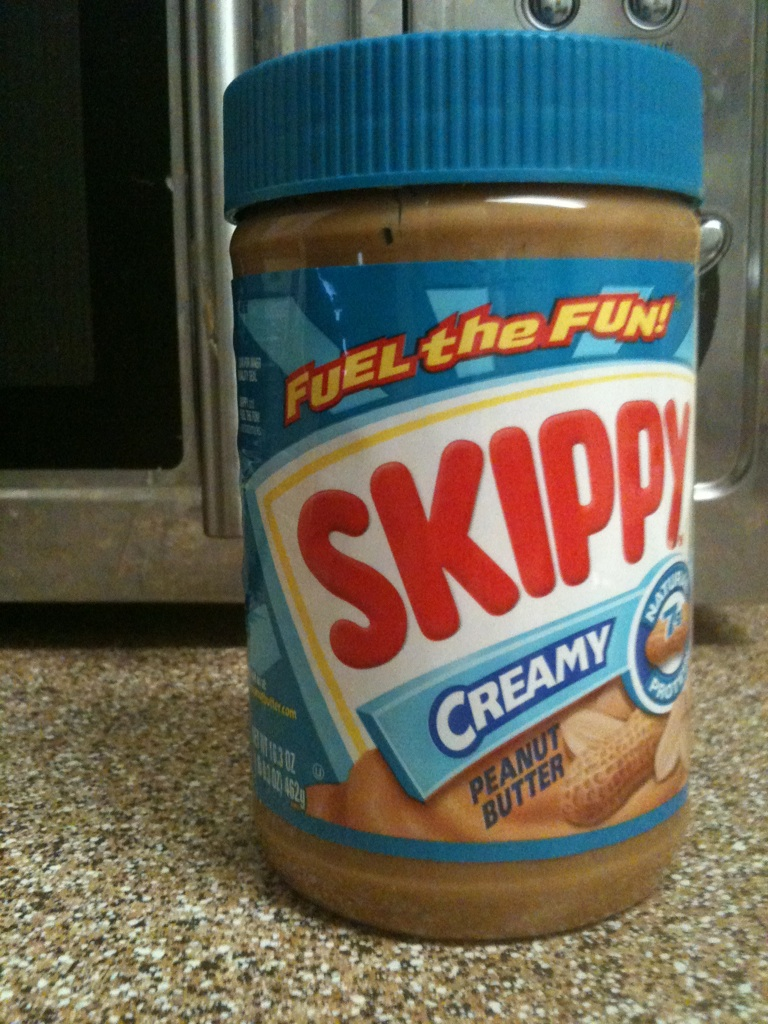What makes Skippy different from other peanut butter brands? Skippy is known for its unique, smooth texture and a slightly sweeter taste compared to some other brands. It uses a special blend of roasted peanuts to achieve its signature flavor and creamy consistency, making it a favorite among peanut butter enthusiasts. 